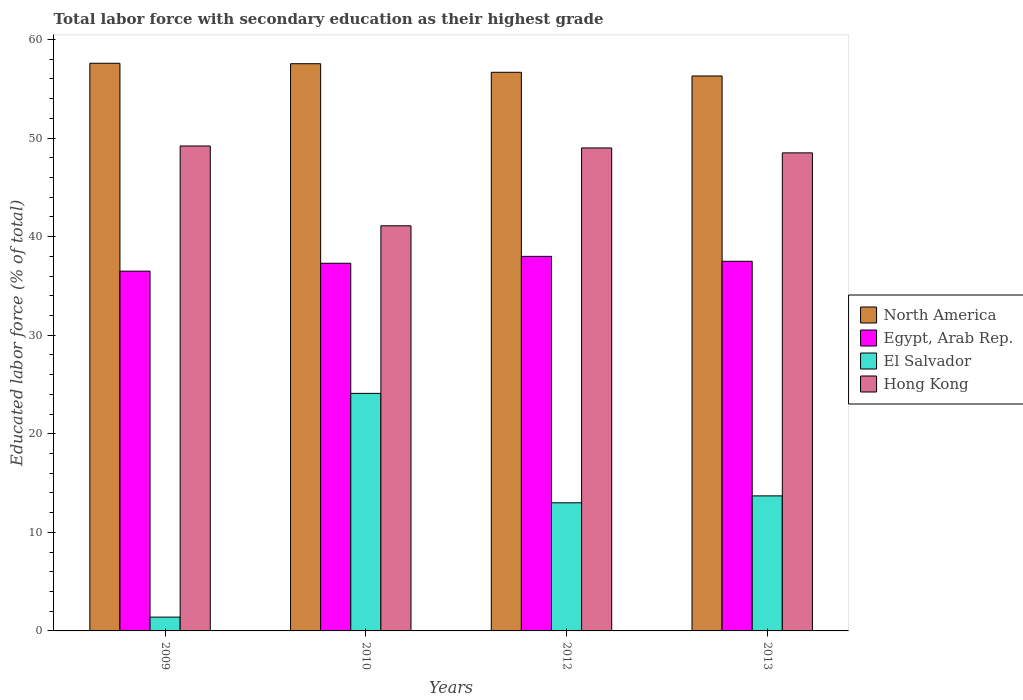What is the label of the 1st group of bars from the left?
Offer a terse response. 2009. In how many cases, is the number of bars for a given year not equal to the number of legend labels?
Give a very brief answer. 0. What is the percentage of total labor force with primary education in El Salvador in 2013?
Offer a terse response. 13.7. Across all years, what is the maximum percentage of total labor force with primary education in Hong Kong?
Keep it short and to the point. 49.2. Across all years, what is the minimum percentage of total labor force with primary education in Egypt, Arab Rep.?
Give a very brief answer. 36.5. In which year was the percentage of total labor force with primary education in Hong Kong maximum?
Your answer should be very brief. 2009. What is the total percentage of total labor force with primary education in El Salvador in the graph?
Ensure brevity in your answer.  52.2. What is the difference between the percentage of total labor force with primary education in El Salvador in 2010 and that in 2012?
Provide a short and direct response. 11.1. What is the difference between the percentage of total labor force with primary education in North America in 2010 and the percentage of total labor force with primary education in Egypt, Arab Rep. in 2012?
Offer a very short reply. 19.55. What is the average percentage of total labor force with primary education in Egypt, Arab Rep. per year?
Offer a terse response. 37.32. In the year 2013, what is the difference between the percentage of total labor force with primary education in North America and percentage of total labor force with primary education in Hong Kong?
Provide a succinct answer. 7.8. In how many years, is the percentage of total labor force with primary education in El Salvador greater than 20 %?
Provide a succinct answer. 1. What is the ratio of the percentage of total labor force with primary education in Hong Kong in 2010 to that in 2013?
Provide a short and direct response. 0.85. Is the percentage of total labor force with primary education in El Salvador in 2012 less than that in 2013?
Ensure brevity in your answer.  Yes. Is the difference between the percentage of total labor force with primary education in North America in 2009 and 2013 greater than the difference between the percentage of total labor force with primary education in Hong Kong in 2009 and 2013?
Make the answer very short. Yes. What is the difference between the highest and the second highest percentage of total labor force with primary education in North America?
Offer a very short reply. 0.05. What is the difference between the highest and the lowest percentage of total labor force with primary education in North America?
Make the answer very short. 1.29. In how many years, is the percentage of total labor force with primary education in El Salvador greater than the average percentage of total labor force with primary education in El Salvador taken over all years?
Ensure brevity in your answer.  2. What does the 2nd bar from the left in 2010 represents?
Give a very brief answer. Egypt, Arab Rep. What does the 3rd bar from the right in 2009 represents?
Your answer should be very brief. Egypt, Arab Rep. Is it the case that in every year, the sum of the percentage of total labor force with primary education in Egypt, Arab Rep. and percentage of total labor force with primary education in El Salvador is greater than the percentage of total labor force with primary education in North America?
Keep it short and to the point. No. How many years are there in the graph?
Provide a succinct answer. 4. What is the difference between two consecutive major ticks on the Y-axis?
Keep it short and to the point. 10. Are the values on the major ticks of Y-axis written in scientific E-notation?
Provide a short and direct response. No. Does the graph contain grids?
Your response must be concise. No. Where does the legend appear in the graph?
Ensure brevity in your answer.  Center right. How are the legend labels stacked?
Provide a short and direct response. Vertical. What is the title of the graph?
Ensure brevity in your answer.  Total labor force with secondary education as their highest grade. What is the label or title of the Y-axis?
Make the answer very short. Educated labor force (% of total). What is the Educated labor force (% of total) of North America in 2009?
Your response must be concise. 57.59. What is the Educated labor force (% of total) in Egypt, Arab Rep. in 2009?
Give a very brief answer. 36.5. What is the Educated labor force (% of total) in El Salvador in 2009?
Provide a short and direct response. 1.4. What is the Educated labor force (% of total) of Hong Kong in 2009?
Provide a succinct answer. 49.2. What is the Educated labor force (% of total) in North America in 2010?
Provide a short and direct response. 57.55. What is the Educated labor force (% of total) of Egypt, Arab Rep. in 2010?
Provide a succinct answer. 37.3. What is the Educated labor force (% of total) of El Salvador in 2010?
Give a very brief answer. 24.1. What is the Educated labor force (% of total) of Hong Kong in 2010?
Give a very brief answer. 41.1. What is the Educated labor force (% of total) of North America in 2012?
Give a very brief answer. 56.67. What is the Educated labor force (% of total) of El Salvador in 2012?
Provide a short and direct response. 13. What is the Educated labor force (% of total) in Hong Kong in 2012?
Offer a very short reply. 49. What is the Educated labor force (% of total) in North America in 2013?
Offer a terse response. 56.3. What is the Educated labor force (% of total) in Egypt, Arab Rep. in 2013?
Provide a succinct answer. 37.5. What is the Educated labor force (% of total) in El Salvador in 2013?
Ensure brevity in your answer.  13.7. What is the Educated labor force (% of total) in Hong Kong in 2013?
Keep it short and to the point. 48.5. Across all years, what is the maximum Educated labor force (% of total) in North America?
Make the answer very short. 57.59. Across all years, what is the maximum Educated labor force (% of total) in El Salvador?
Give a very brief answer. 24.1. Across all years, what is the maximum Educated labor force (% of total) in Hong Kong?
Make the answer very short. 49.2. Across all years, what is the minimum Educated labor force (% of total) in North America?
Offer a very short reply. 56.3. Across all years, what is the minimum Educated labor force (% of total) in Egypt, Arab Rep.?
Keep it short and to the point. 36.5. Across all years, what is the minimum Educated labor force (% of total) in El Salvador?
Offer a terse response. 1.4. Across all years, what is the minimum Educated labor force (% of total) in Hong Kong?
Your answer should be compact. 41.1. What is the total Educated labor force (% of total) in North America in the graph?
Ensure brevity in your answer.  228.11. What is the total Educated labor force (% of total) of Egypt, Arab Rep. in the graph?
Your answer should be very brief. 149.3. What is the total Educated labor force (% of total) of El Salvador in the graph?
Provide a short and direct response. 52.2. What is the total Educated labor force (% of total) of Hong Kong in the graph?
Keep it short and to the point. 187.8. What is the difference between the Educated labor force (% of total) in North America in 2009 and that in 2010?
Ensure brevity in your answer.  0.05. What is the difference between the Educated labor force (% of total) in Egypt, Arab Rep. in 2009 and that in 2010?
Your answer should be compact. -0.8. What is the difference between the Educated labor force (% of total) in El Salvador in 2009 and that in 2010?
Provide a short and direct response. -22.7. What is the difference between the Educated labor force (% of total) in Hong Kong in 2009 and that in 2010?
Ensure brevity in your answer.  8.1. What is the difference between the Educated labor force (% of total) of North America in 2009 and that in 2012?
Your response must be concise. 0.92. What is the difference between the Educated labor force (% of total) of Egypt, Arab Rep. in 2009 and that in 2012?
Make the answer very short. -1.5. What is the difference between the Educated labor force (% of total) in Hong Kong in 2009 and that in 2012?
Provide a short and direct response. 0.2. What is the difference between the Educated labor force (% of total) in North America in 2009 and that in 2013?
Your answer should be very brief. 1.29. What is the difference between the Educated labor force (% of total) of Egypt, Arab Rep. in 2009 and that in 2013?
Keep it short and to the point. -1. What is the difference between the Educated labor force (% of total) in North America in 2010 and that in 2012?
Give a very brief answer. 0.87. What is the difference between the Educated labor force (% of total) of Egypt, Arab Rep. in 2010 and that in 2012?
Ensure brevity in your answer.  -0.7. What is the difference between the Educated labor force (% of total) in Hong Kong in 2010 and that in 2012?
Give a very brief answer. -7.9. What is the difference between the Educated labor force (% of total) in North America in 2010 and that in 2013?
Your response must be concise. 1.24. What is the difference between the Educated labor force (% of total) of Egypt, Arab Rep. in 2010 and that in 2013?
Your answer should be compact. -0.2. What is the difference between the Educated labor force (% of total) in El Salvador in 2010 and that in 2013?
Provide a short and direct response. 10.4. What is the difference between the Educated labor force (% of total) of Hong Kong in 2010 and that in 2013?
Provide a succinct answer. -7.4. What is the difference between the Educated labor force (% of total) of North America in 2012 and that in 2013?
Offer a terse response. 0.37. What is the difference between the Educated labor force (% of total) of Egypt, Arab Rep. in 2012 and that in 2013?
Ensure brevity in your answer.  0.5. What is the difference between the Educated labor force (% of total) of El Salvador in 2012 and that in 2013?
Your answer should be very brief. -0.7. What is the difference between the Educated labor force (% of total) of North America in 2009 and the Educated labor force (% of total) of Egypt, Arab Rep. in 2010?
Provide a succinct answer. 20.29. What is the difference between the Educated labor force (% of total) of North America in 2009 and the Educated labor force (% of total) of El Salvador in 2010?
Keep it short and to the point. 33.49. What is the difference between the Educated labor force (% of total) in North America in 2009 and the Educated labor force (% of total) in Hong Kong in 2010?
Provide a succinct answer. 16.49. What is the difference between the Educated labor force (% of total) in Egypt, Arab Rep. in 2009 and the Educated labor force (% of total) in El Salvador in 2010?
Your answer should be very brief. 12.4. What is the difference between the Educated labor force (% of total) in El Salvador in 2009 and the Educated labor force (% of total) in Hong Kong in 2010?
Keep it short and to the point. -39.7. What is the difference between the Educated labor force (% of total) of North America in 2009 and the Educated labor force (% of total) of Egypt, Arab Rep. in 2012?
Keep it short and to the point. 19.59. What is the difference between the Educated labor force (% of total) of North America in 2009 and the Educated labor force (% of total) of El Salvador in 2012?
Your answer should be compact. 44.59. What is the difference between the Educated labor force (% of total) of North America in 2009 and the Educated labor force (% of total) of Hong Kong in 2012?
Provide a short and direct response. 8.59. What is the difference between the Educated labor force (% of total) in Egypt, Arab Rep. in 2009 and the Educated labor force (% of total) in El Salvador in 2012?
Your response must be concise. 23.5. What is the difference between the Educated labor force (% of total) of Egypt, Arab Rep. in 2009 and the Educated labor force (% of total) of Hong Kong in 2012?
Ensure brevity in your answer.  -12.5. What is the difference between the Educated labor force (% of total) of El Salvador in 2009 and the Educated labor force (% of total) of Hong Kong in 2012?
Make the answer very short. -47.6. What is the difference between the Educated labor force (% of total) of North America in 2009 and the Educated labor force (% of total) of Egypt, Arab Rep. in 2013?
Your response must be concise. 20.09. What is the difference between the Educated labor force (% of total) in North America in 2009 and the Educated labor force (% of total) in El Salvador in 2013?
Ensure brevity in your answer.  43.89. What is the difference between the Educated labor force (% of total) in North America in 2009 and the Educated labor force (% of total) in Hong Kong in 2013?
Your response must be concise. 9.09. What is the difference between the Educated labor force (% of total) in Egypt, Arab Rep. in 2009 and the Educated labor force (% of total) in El Salvador in 2013?
Offer a very short reply. 22.8. What is the difference between the Educated labor force (% of total) of Egypt, Arab Rep. in 2009 and the Educated labor force (% of total) of Hong Kong in 2013?
Give a very brief answer. -12. What is the difference between the Educated labor force (% of total) of El Salvador in 2009 and the Educated labor force (% of total) of Hong Kong in 2013?
Make the answer very short. -47.1. What is the difference between the Educated labor force (% of total) in North America in 2010 and the Educated labor force (% of total) in Egypt, Arab Rep. in 2012?
Offer a very short reply. 19.55. What is the difference between the Educated labor force (% of total) of North America in 2010 and the Educated labor force (% of total) of El Salvador in 2012?
Your answer should be compact. 44.55. What is the difference between the Educated labor force (% of total) of North America in 2010 and the Educated labor force (% of total) of Hong Kong in 2012?
Provide a succinct answer. 8.55. What is the difference between the Educated labor force (% of total) in Egypt, Arab Rep. in 2010 and the Educated labor force (% of total) in El Salvador in 2012?
Provide a short and direct response. 24.3. What is the difference between the Educated labor force (% of total) of Egypt, Arab Rep. in 2010 and the Educated labor force (% of total) of Hong Kong in 2012?
Give a very brief answer. -11.7. What is the difference between the Educated labor force (% of total) of El Salvador in 2010 and the Educated labor force (% of total) of Hong Kong in 2012?
Ensure brevity in your answer.  -24.9. What is the difference between the Educated labor force (% of total) of North America in 2010 and the Educated labor force (% of total) of Egypt, Arab Rep. in 2013?
Offer a terse response. 20.05. What is the difference between the Educated labor force (% of total) in North America in 2010 and the Educated labor force (% of total) in El Salvador in 2013?
Provide a short and direct response. 43.85. What is the difference between the Educated labor force (% of total) of North America in 2010 and the Educated labor force (% of total) of Hong Kong in 2013?
Make the answer very short. 9.05. What is the difference between the Educated labor force (% of total) in Egypt, Arab Rep. in 2010 and the Educated labor force (% of total) in El Salvador in 2013?
Provide a short and direct response. 23.6. What is the difference between the Educated labor force (% of total) of Egypt, Arab Rep. in 2010 and the Educated labor force (% of total) of Hong Kong in 2013?
Offer a terse response. -11.2. What is the difference between the Educated labor force (% of total) in El Salvador in 2010 and the Educated labor force (% of total) in Hong Kong in 2013?
Ensure brevity in your answer.  -24.4. What is the difference between the Educated labor force (% of total) of North America in 2012 and the Educated labor force (% of total) of Egypt, Arab Rep. in 2013?
Offer a very short reply. 19.18. What is the difference between the Educated labor force (% of total) of North America in 2012 and the Educated labor force (% of total) of El Salvador in 2013?
Offer a very short reply. 42.98. What is the difference between the Educated labor force (% of total) of North America in 2012 and the Educated labor force (% of total) of Hong Kong in 2013?
Provide a short and direct response. 8.18. What is the difference between the Educated labor force (% of total) of Egypt, Arab Rep. in 2012 and the Educated labor force (% of total) of El Salvador in 2013?
Provide a succinct answer. 24.3. What is the difference between the Educated labor force (% of total) of El Salvador in 2012 and the Educated labor force (% of total) of Hong Kong in 2013?
Provide a short and direct response. -35.5. What is the average Educated labor force (% of total) of North America per year?
Ensure brevity in your answer.  57.03. What is the average Educated labor force (% of total) of Egypt, Arab Rep. per year?
Provide a succinct answer. 37.33. What is the average Educated labor force (% of total) in El Salvador per year?
Make the answer very short. 13.05. What is the average Educated labor force (% of total) of Hong Kong per year?
Make the answer very short. 46.95. In the year 2009, what is the difference between the Educated labor force (% of total) in North America and Educated labor force (% of total) in Egypt, Arab Rep.?
Provide a succinct answer. 21.09. In the year 2009, what is the difference between the Educated labor force (% of total) of North America and Educated labor force (% of total) of El Salvador?
Give a very brief answer. 56.19. In the year 2009, what is the difference between the Educated labor force (% of total) in North America and Educated labor force (% of total) in Hong Kong?
Offer a terse response. 8.39. In the year 2009, what is the difference between the Educated labor force (% of total) of Egypt, Arab Rep. and Educated labor force (% of total) of El Salvador?
Give a very brief answer. 35.1. In the year 2009, what is the difference between the Educated labor force (% of total) of Egypt, Arab Rep. and Educated labor force (% of total) of Hong Kong?
Ensure brevity in your answer.  -12.7. In the year 2009, what is the difference between the Educated labor force (% of total) in El Salvador and Educated labor force (% of total) in Hong Kong?
Offer a terse response. -47.8. In the year 2010, what is the difference between the Educated labor force (% of total) in North America and Educated labor force (% of total) in Egypt, Arab Rep.?
Offer a terse response. 20.25. In the year 2010, what is the difference between the Educated labor force (% of total) of North America and Educated labor force (% of total) of El Salvador?
Your response must be concise. 33.45. In the year 2010, what is the difference between the Educated labor force (% of total) of North America and Educated labor force (% of total) of Hong Kong?
Ensure brevity in your answer.  16.45. In the year 2010, what is the difference between the Educated labor force (% of total) of Egypt, Arab Rep. and Educated labor force (% of total) of Hong Kong?
Provide a short and direct response. -3.8. In the year 2010, what is the difference between the Educated labor force (% of total) of El Salvador and Educated labor force (% of total) of Hong Kong?
Offer a very short reply. -17. In the year 2012, what is the difference between the Educated labor force (% of total) in North America and Educated labor force (% of total) in Egypt, Arab Rep.?
Give a very brief answer. 18.68. In the year 2012, what is the difference between the Educated labor force (% of total) in North America and Educated labor force (% of total) in El Salvador?
Provide a short and direct response. 43.67. In the year 2012, what is the difference between the Educated labor force (% of total) of North America and Educated labor force (% of total) of Hong Kong?
Keep it short and to the point. 7.67. In the year 2012, what is the difference between the Educated labor force (% of total) of Egypt, Arab Rep. and Educated labor force (% of total) of El Salvador?
Ensure brevity in your answer.  25. In the year 2012, what is the difference between the Educated labor force (% of total) of Egypt, Arab Rep. and Educated labor force (% of total) of Hong Kong?
Your answer should be compact. -11. In the year 2012, what is the difference between the Educated labor force (% of total) of El Salvador and Educated labor force (% of total) of Hong Kong?
Keep it short and to the point. -36. In the year 2013, what is the difference between the Educated labor force (% of total) in North America and Educated labor force (% of total) in Egypt, Arab Rep.?
Offer a terse response. 18.8. In the year 2013, what is the difference between the Educated labor force (% of total) of North America and Educated labor force (% of total) of El Salvador?
Provide a succinct answer. 42.6. In the year 2013, what is the difference between the Educated labor force (% of total) in North America and Educated labor force (% of total) in Hong Kong?
Offer a terse response. 7.8. In the year 2013, what is the difference between the Educated labor force (% of total) in Egypt, Arab Rep. and Educated labor force (% of total) in El Salvador?
Give a very brief answer. 23.8. In the year 2013, what is the difference between the Educated labor force (% of total) of El Salvador and Educated labor force (% of total) of Hong Kong?
Offer a very short reply. -34.8. What is the ratio of the Educated labor force (% of total) of North America in 2009 to that in 2010?
Make the answer very short. 1. What is the ratio of the Educated labor force (% of total) in Egypt, Arab Rep. in 2009 to that in 2010?
Make the answer very short. 0.98. What is the ratio of the Educated labor force (% of total) in El Salvador in 2009 to that in 2010?
Your answer should be very brief. 0.06. What is the ratio of the Educated labor force (% of total) in Hong Kong in 2009 to that in 2010?
Make the answer very short. 1.2. What is the ratio of the Educated labor force (% of total) in North America in 2009 to that in 2012?
Keep it short and to the point. 1.02. What is the ratio of the Educated labor force (% of total) of Egypt, Arab Rep. in 2009 to that in 2012?
Give a very brief answer. 0.96. What is the ratio of the Educated labor force (% of total) of El Salvador in 2009 to that in 2012?
Your response must be concise. 0.11. What is the ratio of the Educated labor force (% of total) of North America in 2009 to that in 2013?
Offer a terse response. 1.02. What is the ratio of the Educated labor force (% of total) in Egypt, Arab Rep. in 2009 to that in 2013?
Provide a succinct answer. 0.97. What is the ratio of the Educated labor force (% of total) in El Salvador in 2009 to that in 2013?
Your answer should be very brief. 0.1. What is the ratio of the Educated labor force (% of total) in Hong Kong in 2009 to that in 2013?
Offer a terse response. 1.01. What is the ratio of the Educated labor force (% of total) of North America in 2010 to that in 2012?
Your answer should be very brief. 1.02. What is the ratio of the Educated labor force (% of total) of Egypt, Arab Rep. in 2010 to that in 2012?
Your answer should be compact. 0.98. What is the ratio of the Educated labor force (% of total) in El Salvador in 2010 to that in 2012?
Ensure brevity in your answer.  1.85. What is the ratio of the Educated labor force (% of total) in Hong Kong in 2010 to that in 2012?
Your answer should be compact. 0.84. What is the ratio of the Educated labor force (% of total) in North America in 2010 to that in 2013?
Give a very brief answer. 1.02. What is the ratio of the Educated labor force (% of total) of El Salvador in 2010 to that in 2013?
Provide a succinct answer. 1.76. What is the ratio of the Educated labor force (% of total) in Hong Kong in 2010 to that in 2013?
Offer a terse response. 0.85. What is the ratio of the Educated labor force (% of total) in North America in 2012 to that in 2013?
Provide a succinct answer. 1.01. What is the ratio of the Educated labor force (% of total) of Egypt, Arab Rep. in 2012 to that in 2013?
Keep it short and to the point. 1.01. What is the ratio of the Educated labor force (% of total) in El Salvador in 2012 to that in 2013?
Your answer should be very brief. 0.95. What is the ratio of the Educated labor force (% of total) in Hong Kong in 2012 to that in 2013?
Your answer should be compact. 1.01. What is the difference between the highest and the second highest Educated labor force (% of total) of North America?
Provide a short and direct response. 0.05. What is the difference between the highest and the second highest Educated labor force (% of total) of El Salvador?
Provide a short and direct response. 10.4. What is the difference between the highest and the second highest Educated labor force (% of total) in Hong Kong?
Provide a succinct answer. 0.2. What is the difference between the highest and the lowest Educated labor force (% of total) of North America?
Offer a very short reply. 1.29. What is the difference between the highest and the lowest Educated labor force (% of total) in El Salvador?
Your response must be concise. 22.7. 